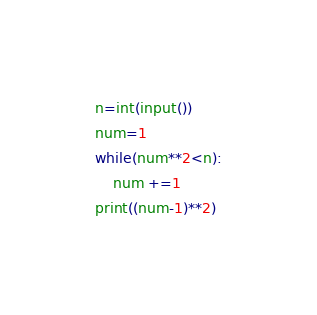<code> <loc_0><loc_0><loc_500><loc_500><_Python_>n=int(input())
num=1
while(num**2<n):
    num +=1
print((num-1)**2)</code> 